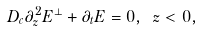<formula> <loc_0><loc_0><loc_500><loc_500>D _ { c } \partial _ { z } ^ { 2 } { E } ^ { \perp } + \partial _ { t } { E } = 0 , \ z < 0 ,</formula> 